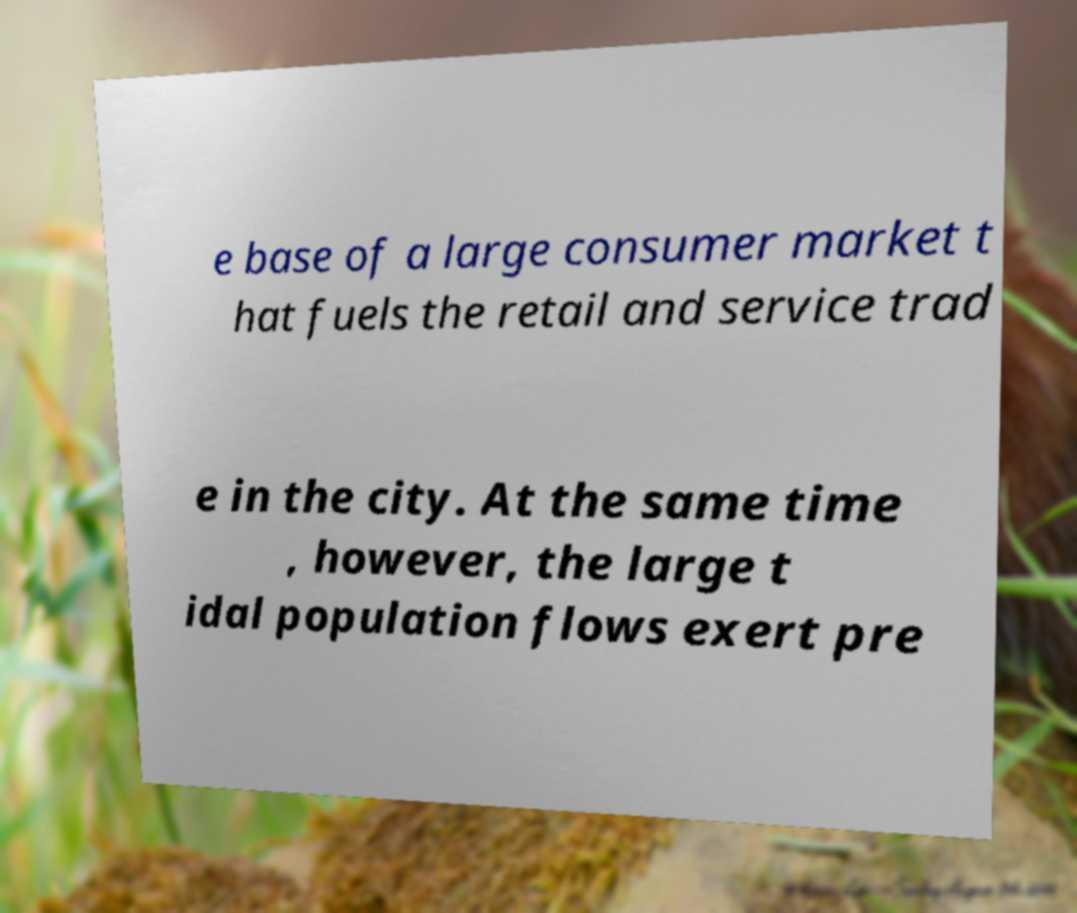Could you assist in decoding the text presented in this image and type it out clearly? e base of a large consumer market t hat fuels the retail and service trad e in the city. At the same time , however, the large t idal population flows exert pre 